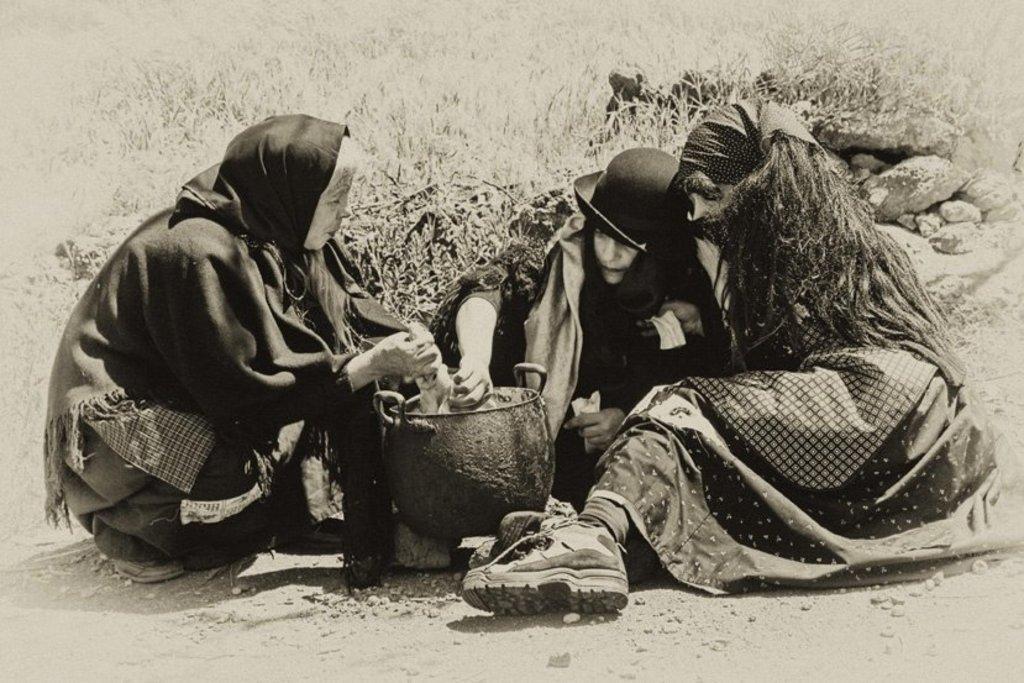How would you summarize this image in a sentence or two? In this image, we can see persons wearing clothes. There is a dish in the middle of the image. There are some plants at the top of the image. 